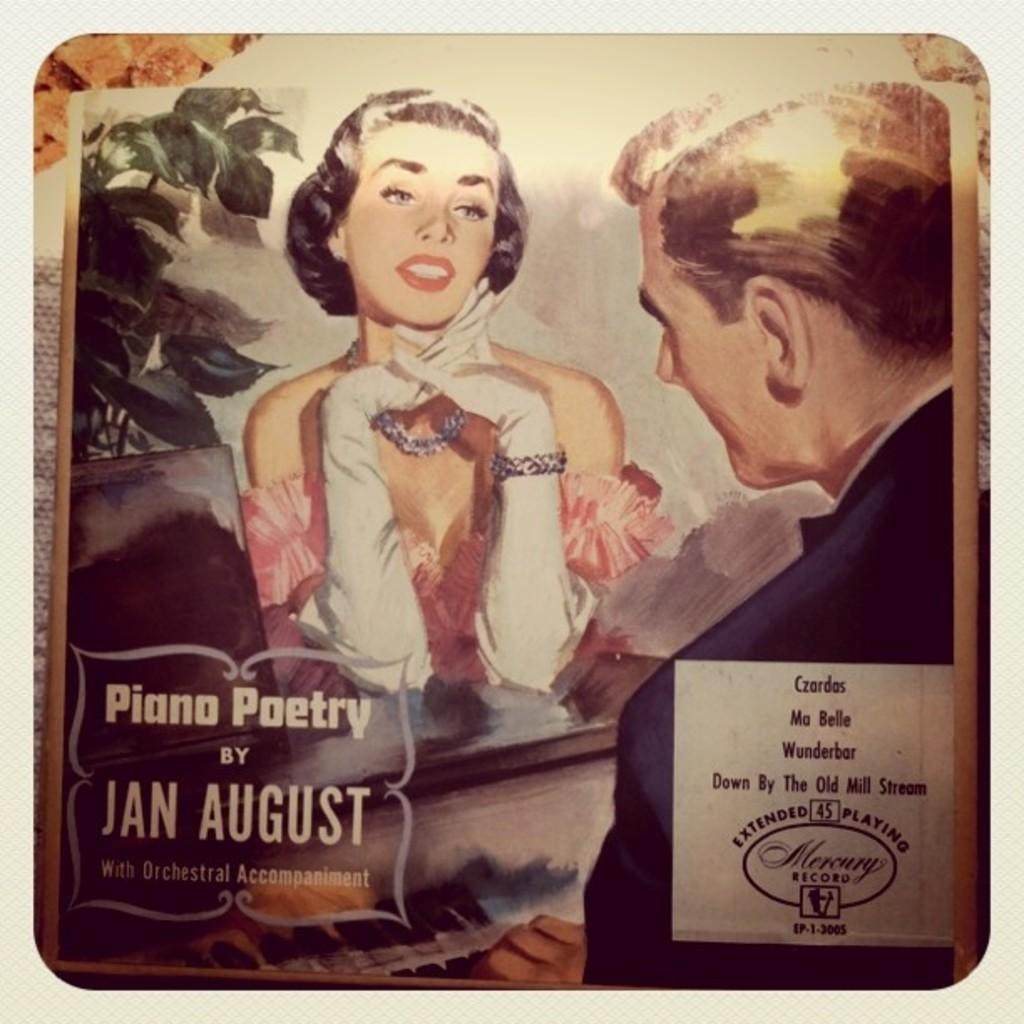What is the main subject of the image? The main subject of the image is a photo. How many people are in the image? There are two persons in the image. What else can be seen in the image besides the people? There is a musical instrument and a plant in the image. Can you describe the appearance of the plant? The plant appears to be partially cut off or "truncated" in the image. Is there any text present in the image? Yes, there is text in the image. What is the color of the background in the image? The background of the image is white in color. How many cats are waving good-bye in the image? There are no cats present in the image, and no one is waving good-bye. Is there any visible wound on the persons in the image? There is no indication of any wound on the persons in the image. 